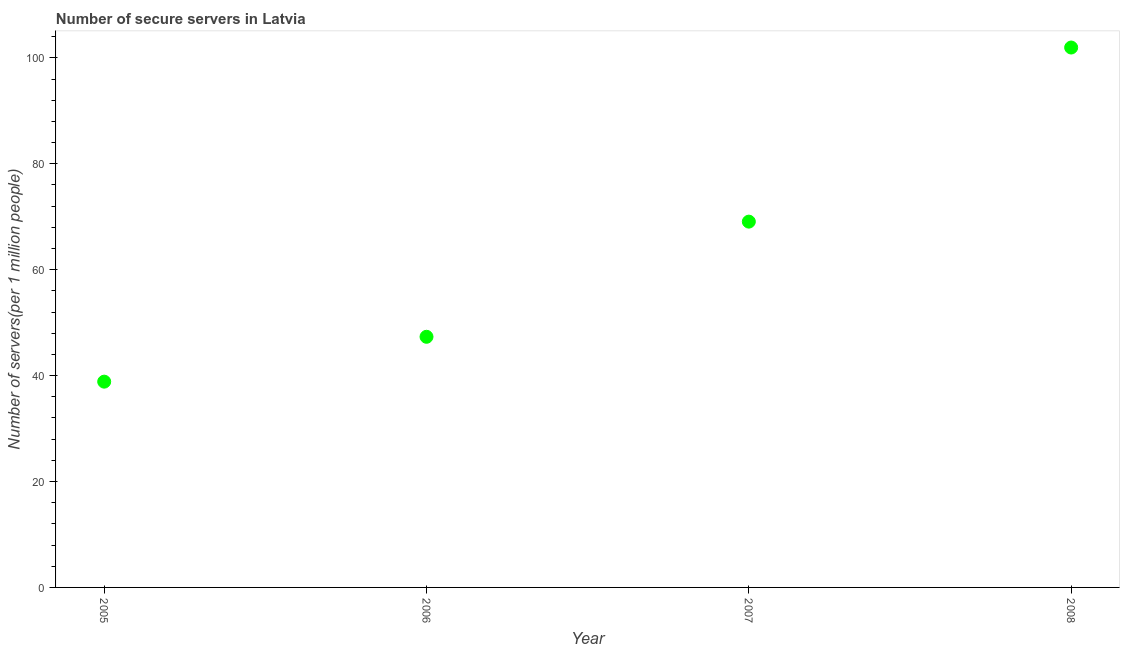What is the number of secure internet servers in 2006?
Give a very brief answer. 47.33. Across all years, what is the maximum number of secure internet servers?
Make the answer very short. 101.96. Across all years, what is the minimum number of secure internet servers?
Your response must be concise. 38.86. What is the sum of the number of secure internet servers?
Keep it short and to the point. 257.23. What is the difference between the number of secure internet servers in 2005 and 2006?
Offer a very short reply. -8.47. What is the average number of secure internet servers per year?
Offer a terse response. 64.31. What is the median number of secure internet servers?
Ensure brevity in your answer.  58.21. What is the ratio of the number of secure internet servers in 2005 to that in 2007?
Your response must be concise. 0.56. Is the difference between the number of secure internet servers in 2007 and 2008 greater than the difference between any two years?
Offer a terse response. No. What is the difference between the highest and the second highest number of secure internet servers?
Offer a very short reply. 32.88. What is the difference between the highest and the lowest number of secure internet servers?
Keep it short and to the point. 63.1. In how many years, is the number of secure internet servers greater than the average number of secure internet servers taken over all years?
Keep it short and to the point. 2. Does the number of secure internet servers monotonically increase over the years?
Make the answer very short. Yes. What is the difference between two consecutive major ticks on the Y-axis?
Ensure brevity in your answer.  20. Are the values on the major ticks of Y-axis written in scientific E-notation?
Provide a short and direct response. No. What is the title of the graph?
Offer a very short reply. Number of secure servers in Latvia. What is the label or title of the X-axis?
Your response must be concise. Year. What is the label or title of the Y-axis?
Your answer should be compact. Number of servers(per 1 million people). What is the Number of servers(per 1 million people) in 2005?
Keep it short and to the point. 38.86. What is the Number of servers(per 1 million people) in 2006?
Your response must be concise. 47.33. What is the Number of servers(per 1 million people) in 2007?
Your answer should be very brief. 69.08. What is the Number of servers(per 1 million people) in 2008?
Offer a very short reply. 101.96. What is the difference between the Number of servers(per 1 million people) in 2005 and 2006?
Give a very brief answer. -8.47. What is the difference between the Number of servers(per 1 million people) in 2005 and 2007?
Your response must be concise. -30.22. What is the difference between the Number of servers(per 1 million people) in 2005 and 2008?
Your answer should be compact. -63.1. What is the difference between the Number of servers(per 1 million people) in 2006 and 2007?
Your answer should be very brief. -21.75. What is the difference between the Number of servers(per 1 million people) in 2006 and 2008?
Make the answer very short. -54.63. What is the difference between the Number of servers(per 1 million people) in 2007 and 2008?
Make the answer very short. -32.88. What is the ratio of the Number of servers(per 1 million people) in 2005 to that in 2006?
Ensure brevity in your answer.  0.82. What is the ratio of the Number of servers(per 1 million people) in 2005 to that in 2007?
Make the answer very short. 0.56. What is the ratio of the Number of servers(per 1 million people) in 2005 to that in 2008?
Your answer should be compact. 0.38. What is the ratio of the Number of servers(per 1 million people) in 2006 to that in 2007?
Your answer should be compact. 0.69. What is the ratio of the Number of servers(per 1 million people) in 2006 to that in 2008?
Make the answer very short. 0.46. What is the ratio of the Number of servers(per 1 million people) in 2007 to that in 2008?
Keep it short and to the point. 0.68. 